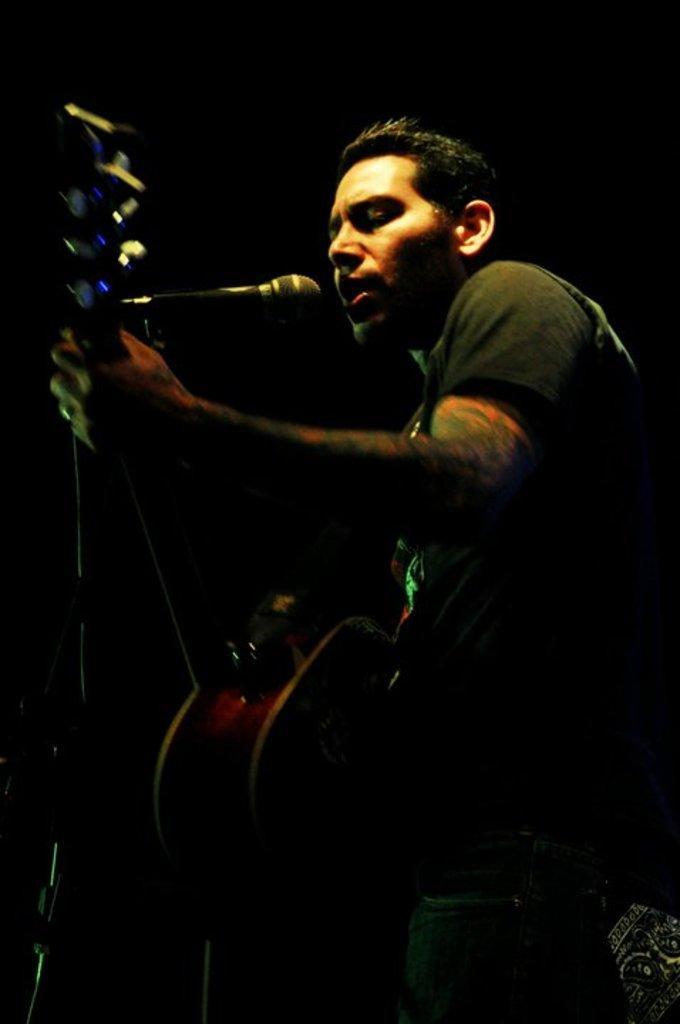Can you describe this image briefly? In this picture we see a man in black t-shirt is holding guitar in his hand and he is playing it. He is even singing on microphone. 